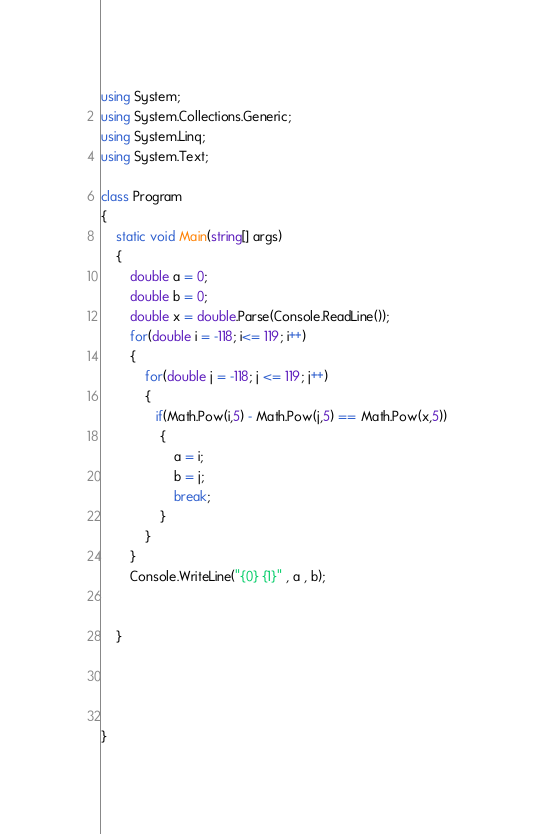Convert code to text. <code><loc_0><loc_0><loc_500><loc_500><_C#_>using System;
using System.Collections.Generic;
using System.Linq;
using System.Text;

class Program
{
    static void Main(string[] args)
    {
        double a = 0;
        double b = 0;
        double x = double.Parse(Console.ReadLine());
        for(double i = -118; i<= 119; i++)
        {
            for(double j = -118; j <= 119; j++)
            {
               if(Math.Pow(i,5) - Math.Pow(j,5) == Math.Pow(x,5))
                {
                    a = i;
                    b = j;
                    break;
                }
            }
        }
        Console.WriteLine("{0} {1}" , a , b);
        

    }




}



</code> 